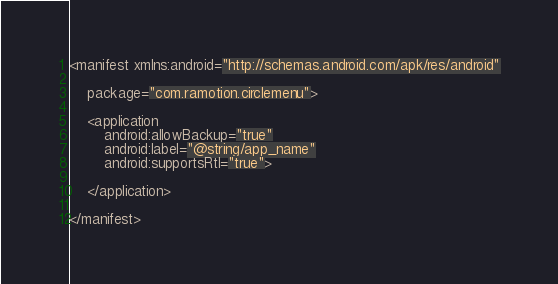Convert code to text. <code><loc_0><loc_0><loc_500><loc_500><_XML_><manifest xmlns:android="http://schemas.android.com/apk/res/android"

    package="com.ramotion.circlemenu">

    <application
        android:allowBackup="true"
        android:label="@string/app_name"
        android:supportsRtl="true">

    </application>

</manifest>
</code> 